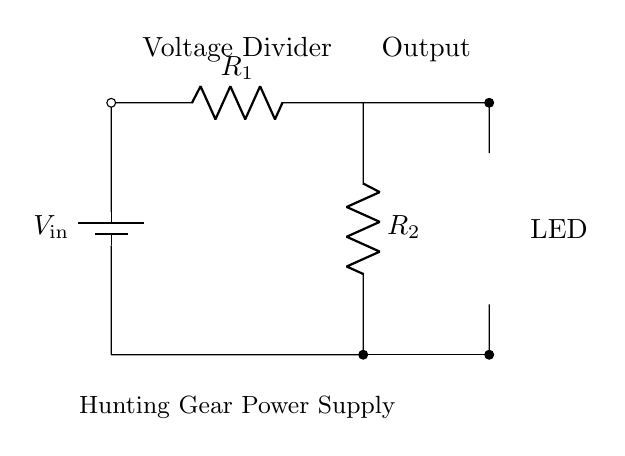What is the function of the resistors R1 and R2? R1 and R2 create a voltage divider to adjust the input voltage to a lower output voltage suitable for the LED.
Answer: Voltage divider What is the output voltage from the voltage divider? The output voltage can be calculated using the voltage divider formula, which is Vout = Vin * (R2 / (R1 + R2)). The values of R1 and R2 would be needed, but the diagram does not provide them specifically.
Answer: Vout = Vin * (R2 / (R1 + R2)) What type of component is shown to the right of R2? The component is an LED (Light Emitting Diode), which lights up when current flows through it in the forward direction.
Answer: LED What does the term "Power Supply" indicate in the context of this circuit? The term "Power Supply" indicates that the circuit is designed to convert a higher input voltage into a usable voltage output to power the LED, which is a common requirement for lighting applications.
Answer: Converts voltage How does the circuit ensure the LED receives the appropriate voltage? The circuit uses a voltage divider consisting of R1 and R2 to reduce the input voltage to a level that is safe for the LED, ensuring it operates within its specified voltage range.
Answer: Uses voltage divider What happens if R1 or R2 values are too high? If R1 or R2 values are too high, the output voltage will be lower, potentially causing the LED not to light up, as it may not receive the necessary forward voltage.
Answer: LED may not light 